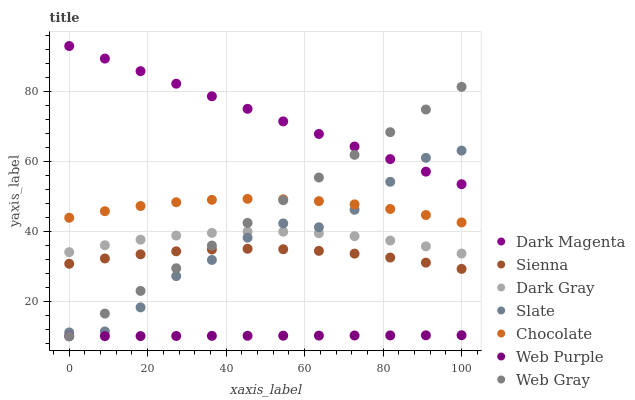Does Web Purple have the minimum area under the curve?
Answer yes or no. Yes. Does Dark Magenta have the maximum area under the curve?
Answer yes or no. Yes. Does Web Gray have the minimum area under the curve?
Answer yes or no. No. Does Web Gray have the maximum area under the curve?
Answer yes or no. No. Is Web Gray the smoothest?
Answer yes or no. Yes. Is Slate the roughest?
Answer yes or no. Yes. Is Dark Magenta the smoothest?
Answer yes or no. No. Is Dark Magenta the roughest?
Answer yes or no. No. Does Web Gray have the lowest value?
Answer yes or no. Yes. Does Dark Magenta have the lowest value?
Answer yes or no. No. Does Dark Magenta have the highest value?
Answer yes or no. Yes. Does Web Gray have the highest value?
Answer yes or no. No. Is Sienna less than Chocolate?
Answer yes or no. Yes. Is Dark Magenta greater than Chocolate?
Answer yes or no. Yes. Does Slate intersect Dark Magenta?
Answer yes or no. Yes. Is Slate less than Dark Magenta?
Answer yes or no. No. Is Slate greater than Dark Magenta?
Answer yes or no. No. Does Sienna intersect Chocolate?
Answer yes or no. No. 